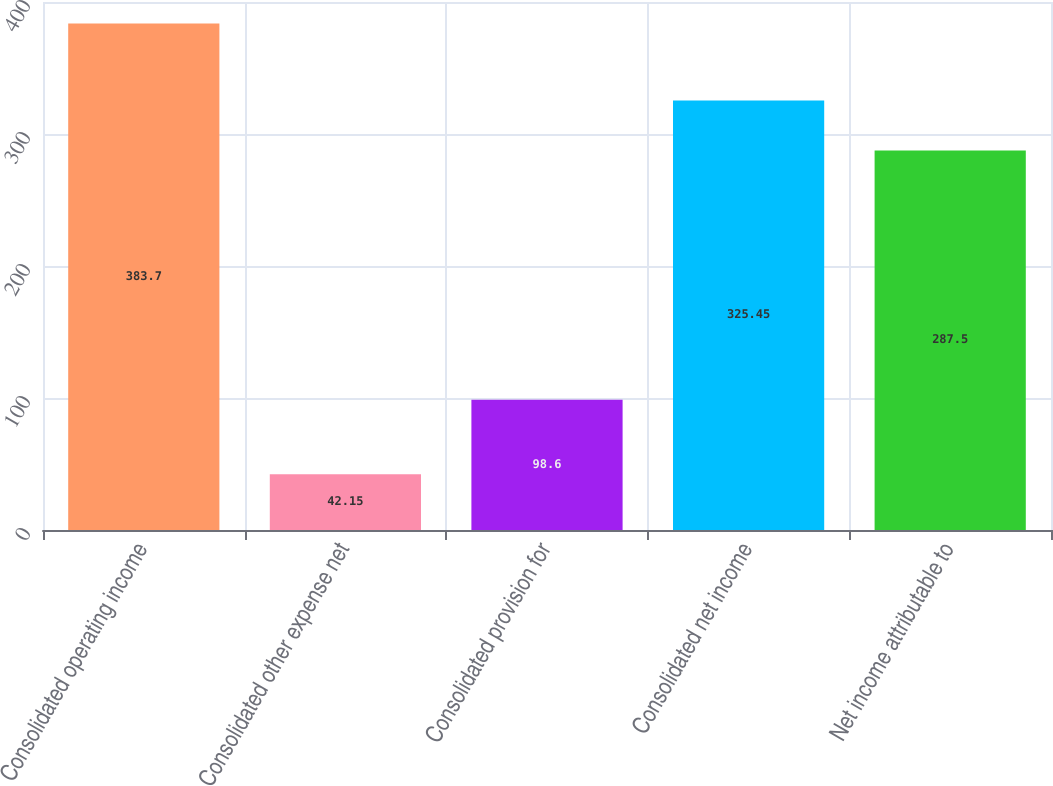Convert chart. <chart><loc_0><loc_0><loc_500><loc_500><bar_chart><fcel>Consolidated operating income<fcel>Consolidated other expense net<fcel>Consolidated provision for<fcel>Consolidated net income<fcel>Net income attributable to<nl><fcel>383.7<fcel>42.15<fcel>98.6<fcel>325.45<fcel>287.5<nl></chart> 